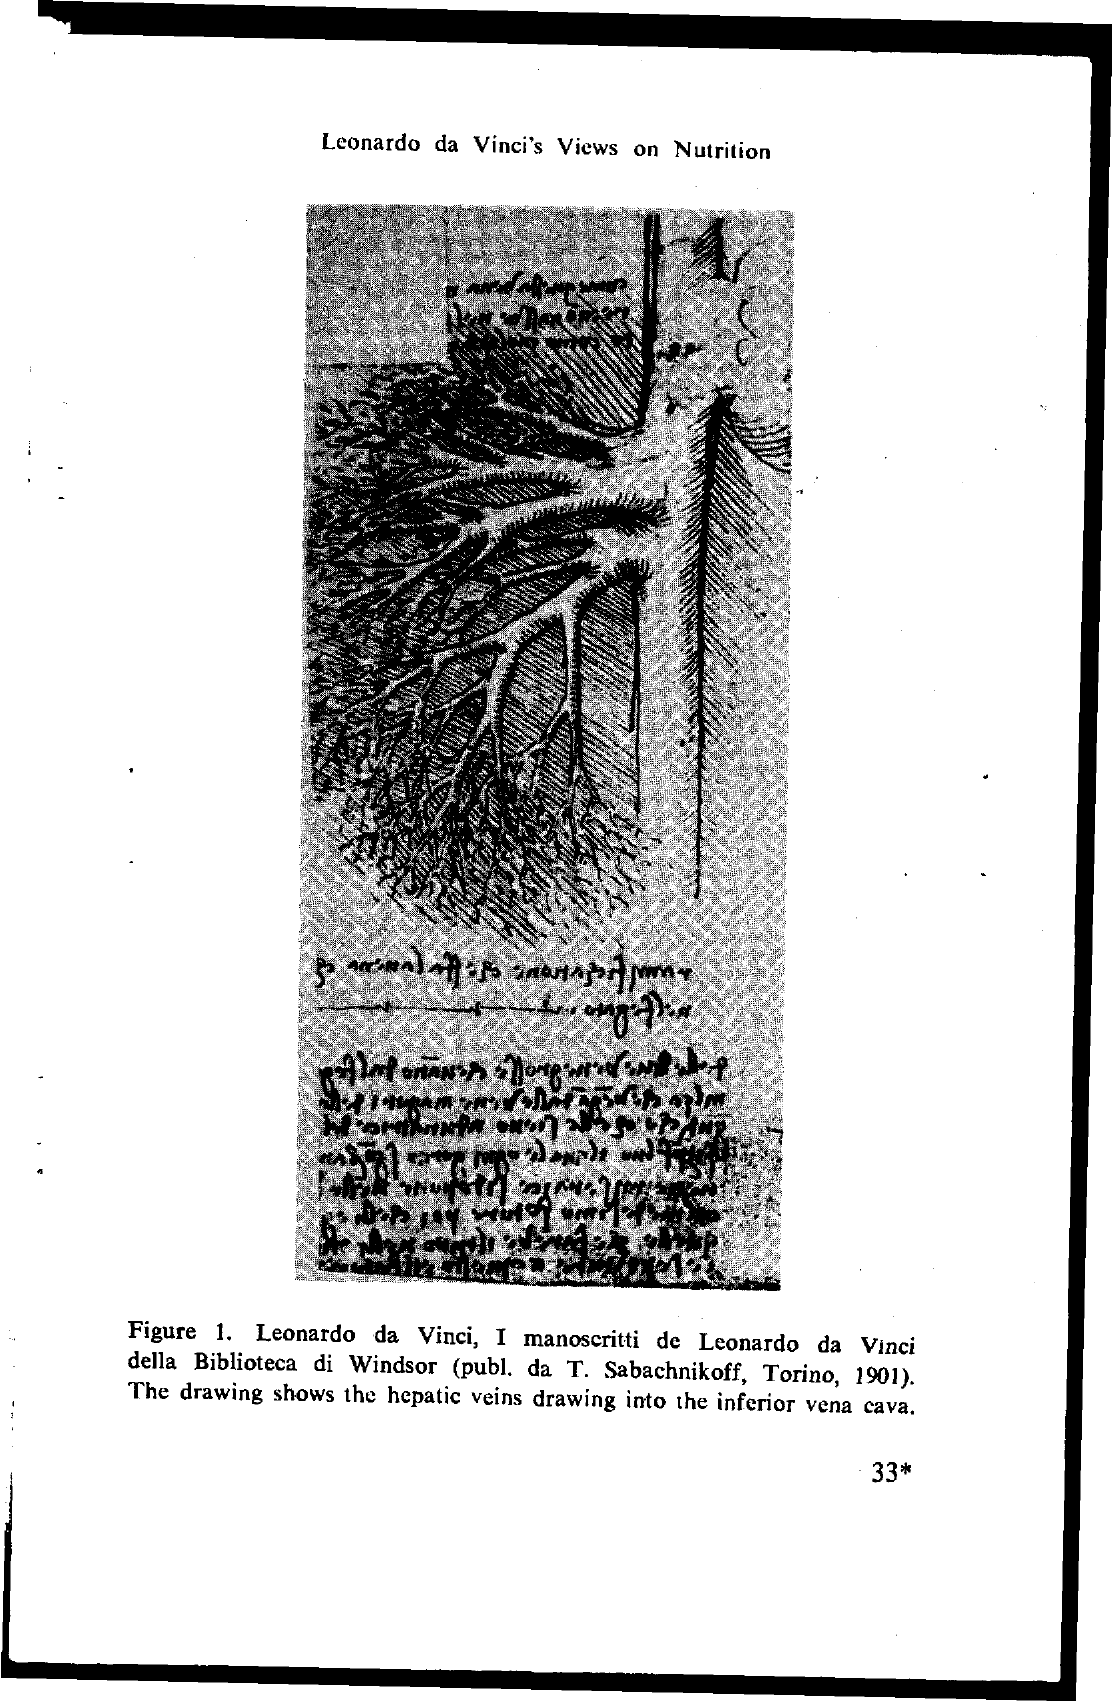List a handful of essential elements in this visual. Leonardo da Vinci's views on nutrition are given in the page. The title of the webpage is 'Leonardo da Vinci's Views on Nutrition.' The page number at the bottom of the page is 33. 